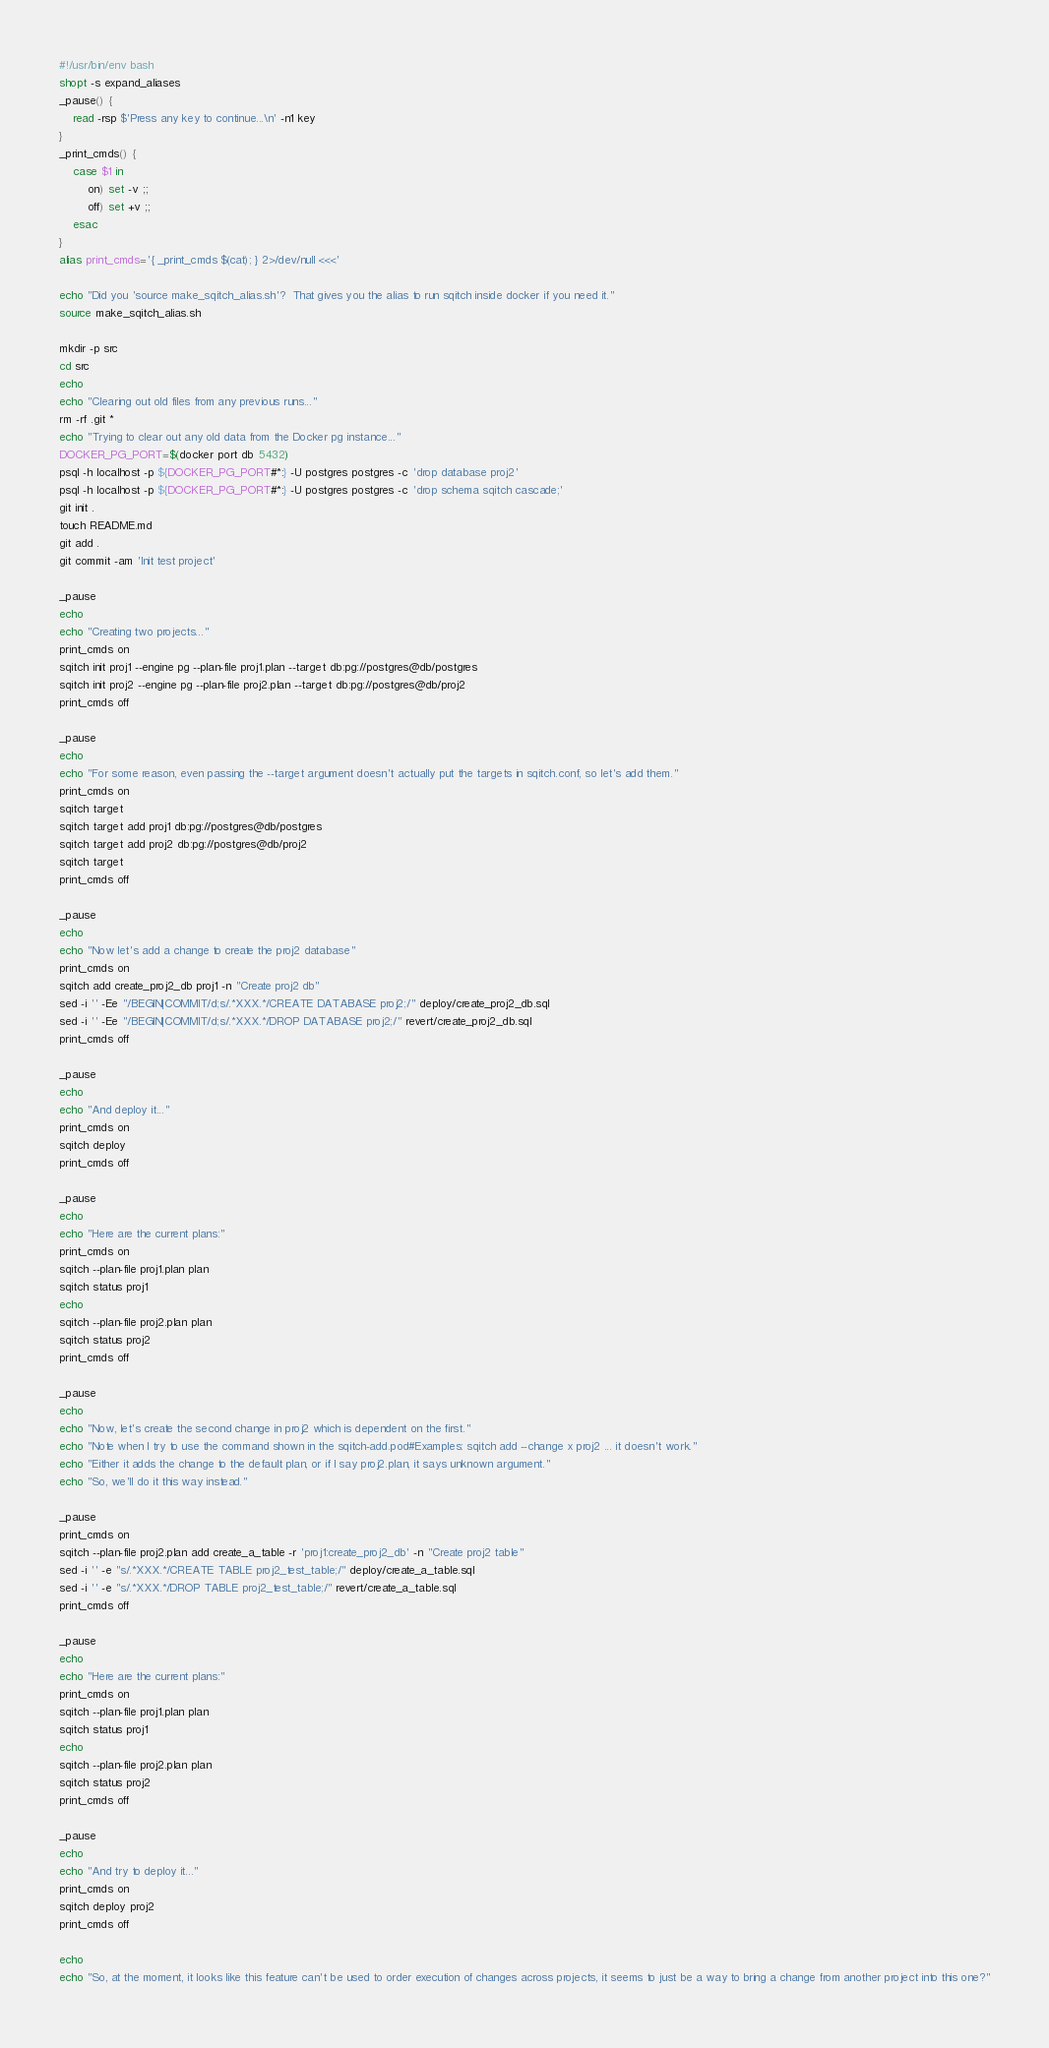<code> <loc_0><loc_0><loc_500><loc_500><_Bash_>#!/usr/bin/env bash 
shopt -s expand_aliases
_pause() {
    read -rsp $'Press any key to continue...\n' -n1 key
}
_print_cmds() {
    case $1 in
        on) set -v ;;
        off) set +v ;;
    esac
}
alias print_cmds='{ _print_cmds $(cat); } 2>/dev/null <<<'

echo "Did you 'source make_sqitch_alias.sh'?  That gives you the alias to run sqitch inside docker if you need it."
source make_sqitch_alias.sh

mkdir -p src
cd src
echo
echo "Clearing out old files from any previous runs..."
rm -rf .git *
echo "Trying to clear out any old data from the Docker pg instance..."
DOCKER_PG_PORT=$(docker port db 5432)
psql -h localhost -p ${DOCKER_PG_PORT#*:} -U postgres postgres -c 'drop database proj2'
psql -h localhost -p ${DOCKER_PG_PORT#*:} -U postgres postgres -c 'drop schema sqitch cascade;'
git init .
touch README.md
git add .
git commit -am 'Init test project'

_pause
echo
echo "Creating two projects..."
print_cmds on
sqitch init proj1 --engine pg --plan-file proj1.plan --target db:pg://postgres@db/postgres
sqitch init proj2 --engine pg --plan-file proj2.plan --target db:pg://postgres@db/proj2
print_cmds off

_pause
echo
echo "For some reason, even passing the --target argument doesn't actually put the targets in sqitch.conf, so let's add them."
print_cmds on
sqitch target
sqitch target add proj1 db:pg://postgres@db/postgres
sqitch target add proj2 db:pg://postgres@db/proj2
sqitch target
print_cmds off

_pause
echo
echo "Now let's add a change to create the proj2 database"
print_cmds on
sqitch add create_proj2_db proj1 -n "Create proj2 db"
sed -i '' -Ee "/BEGIN|COMMIT/d;s/.*XXX.*/CREATE DATABASE proj2;/" deploy/create_proj2_db.sql
sed -i '' -Ee "/BEGIN|COMMIT/d;s/.*XXX.*/DROP DATABASE proj2;/" revert/create_proj2_db.sql
print_cmds off

_pause
echo
echo "And deploy it..."
print_cmds on
sqitch deploy
print_cmds off

_pause
echo
echo "Here are the current plans:"
print_cmds on
sqitch --plan-file proj1.plan plan
sqitch status proj1
echo
sqitch --plan-file proj2.plan plan
sqitch status proj2
print_cmds off

_pause
echo
echo "Now, let's create the second change in proj2 which is dependent on the first."
echo "Note when I try to use the command shown in the sqitch-add.pod#Examples: sqitch add --change x proj2 ... it doesn't work."
echo "Either it adds the change to the default plan, or if I say proj2.plan, it says unknown argument."
echo "So, we'll do it this way instead."

_pause
print_cmds on
sqitch --plan-file proj2.plan add create_a_table -r 'proj1:create_proj2_db' -n "Create proj2 table"
sed -i '' -e "s/.*XXX.*/CREATE TABLE proj2_test_table;/" deploy/create_a_table.sql
sed -i '' -e "s/.*XXX.*/DROP TABLE proj2_test_table;/" revert/create_a_table.sql
print_cmds off

_pause
echo
echo "Here are the current plans:"
print_cmds on
sqitch --plan-file proj1.plan plan
sqitch status proj1
echo
sqitch --plan-file proj2.plan plan
sqitch status proj2
print_cmds off

_pause
echo
echo "And try to deploy it..."
print_cmds on
sqitch deploy proj2
print_cmds off

echo
echo "So, at the moment, it looks like this feature can't be used to order execution of changes across projects, it seems to just be a way to bring a change from another project into this one?"
</code> 